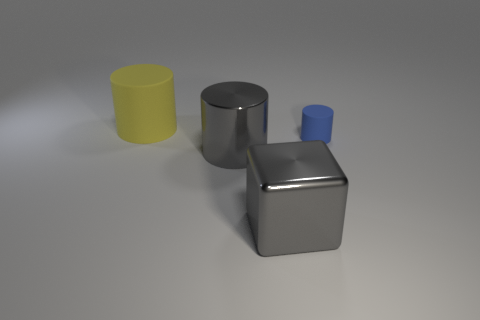Add 3 large gray cubes. How many objects exist? 7 Subtract all yellow cylinders. How many cylinders are left? 2 Subtract all blocks. How many objects are left? 3 Subtract 1 blocks. How many blocks are left? 0 Subtract all yellow cylinders. How many cylinders are left? 2 Add 1 yellow matte things. How many yellow matte things exist? 2 Subtract 0 yellow balls. How many objects are left? 4 Subtract all gray cylinders. Subtract all purple cubes. How many cylinders are left? 2 Subtract all large metal cylinders. Subtract all tiny blue matte blocks. How many objects are left? 3 Add 4 big rubber things. How many big rubber things are left? 5 